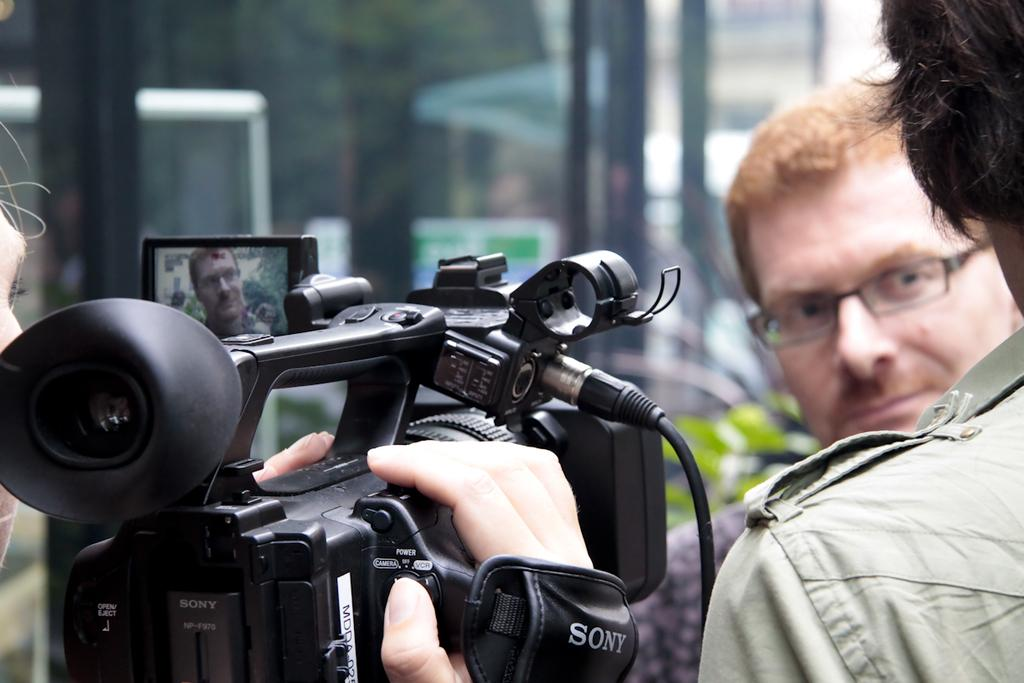What is the person on the left side of the image doing? The person on the left side of the image is holding a camera. Can you describe the people on the right side of the image? There are two people on the right side of the image. What type of memory does the person on the left side of the image have? There is no information about the person's memory in the image. 